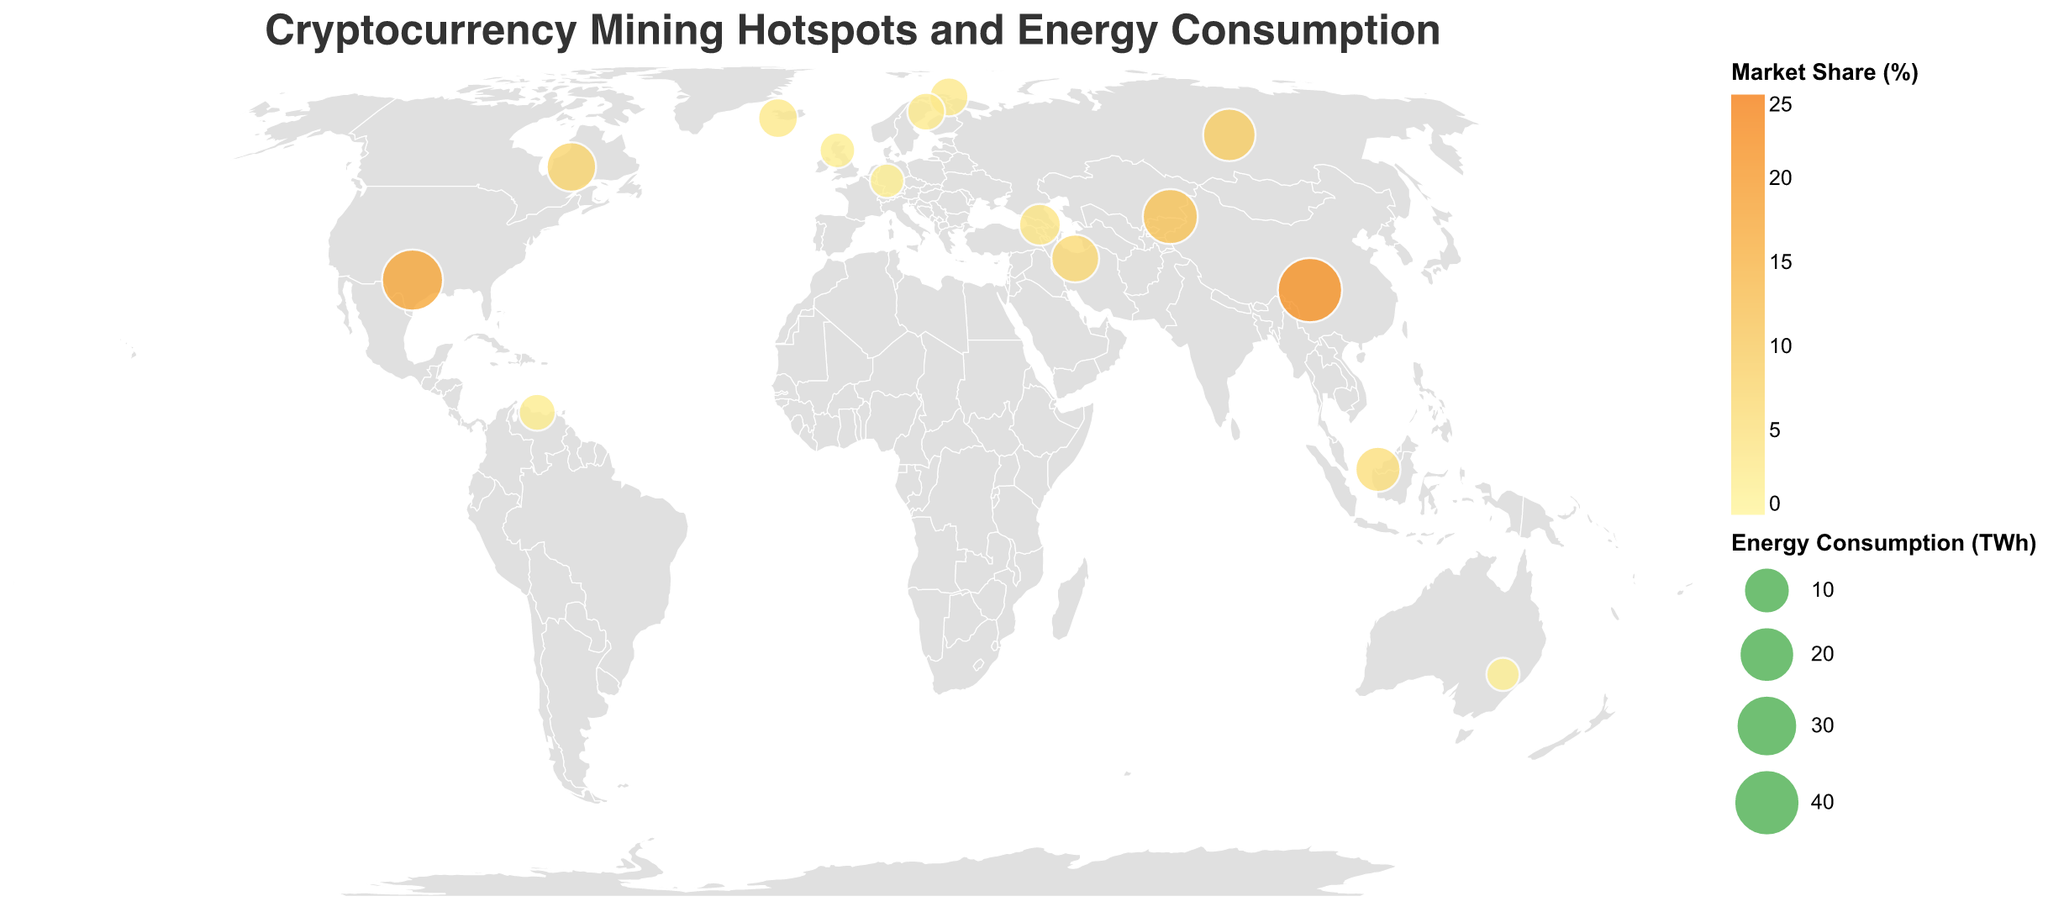What is the title of the figure? The title is usually prominently displayed at the top of the figure. In this case, the title is "Cryptocurrency Mining Hotspots and Energy Consumption".
Answer: Cryptocurrency Mining Hotspots and Energy Consumption Which country has the highest energy consumption for cryptocurrency mining? To find the country with the highest energy consumption, look for the largest circle in the figure. The largest circle, representing the highest energy consumption of 35.2 TWh, is located in China.
Answer: China How much energy does Kazakhstan consume for cryptocurrency mining? Find the circle located in Kazakhstan and refer to the tooltip or legend associated with it. The energy consumption for Kazakhstan is 18.9 TWh.
Answer: 18.9 TWh What is the market share percentage for cryptocurrency mining in Iran? Locate the circle on the map for Iran and refer to its tooltip to find the market share percentage. The market share in Iran is 6.6%.
Answer: 6.6% Compare the energy consumption between Texas, USA, and Sichuan, China. Which has higher consumption and by how much? Find the circles representing Texas and Sichuan, and refer to their energy consumption values. Energy consumption in Texas is 28.7 TWh and in Sichuan is 35.2 TWh. Calculate the difference: 35.2 TWh - 28.7 TWh = 6.5 TWh.
Answer: Sichuan has higher consumption by 6.5 TWh Which country has the second highest market share percentage? Identify the country with the second largest value in the legend for market share percentage. The country with the second largest market share percentage of 17.5% is the United States.
Answer: United States What is the total energy consumption of the top three countries? Find the energy consumption values for the top three countries: China (35.2 TWh), United States (28.7 TWh), and Kazakhstan (18.9 TWh). Sum these values: 35.2 + 28.7 + 18.9 = 82.8 TWh.
Answer: 82.8 TWh What's the average market share percentage among all the listed countries? Calculate the sum of the market share percentages for all countries: 21.5 + 17.5 + 11.5 + 9.5 + 7.5 + 6.6 + 5.2 + 3.8 + 3.1 + 2.9 + 2.6 + 2.3 + 2.0 + 1.8 + 1.5 = 97.3%, and then divide by the number of countries (15): 97.3 / 15 ≈ 6.49%.
Answer: 6.49% Which country's mining hotspot is represented by the circle closest to the equator? Find the circle closest to the equator (latitude 0°). The circle closest to the equator is in Malaysia (Sarawak) with a latitude of 1.5533.
Answer: Malaysia 